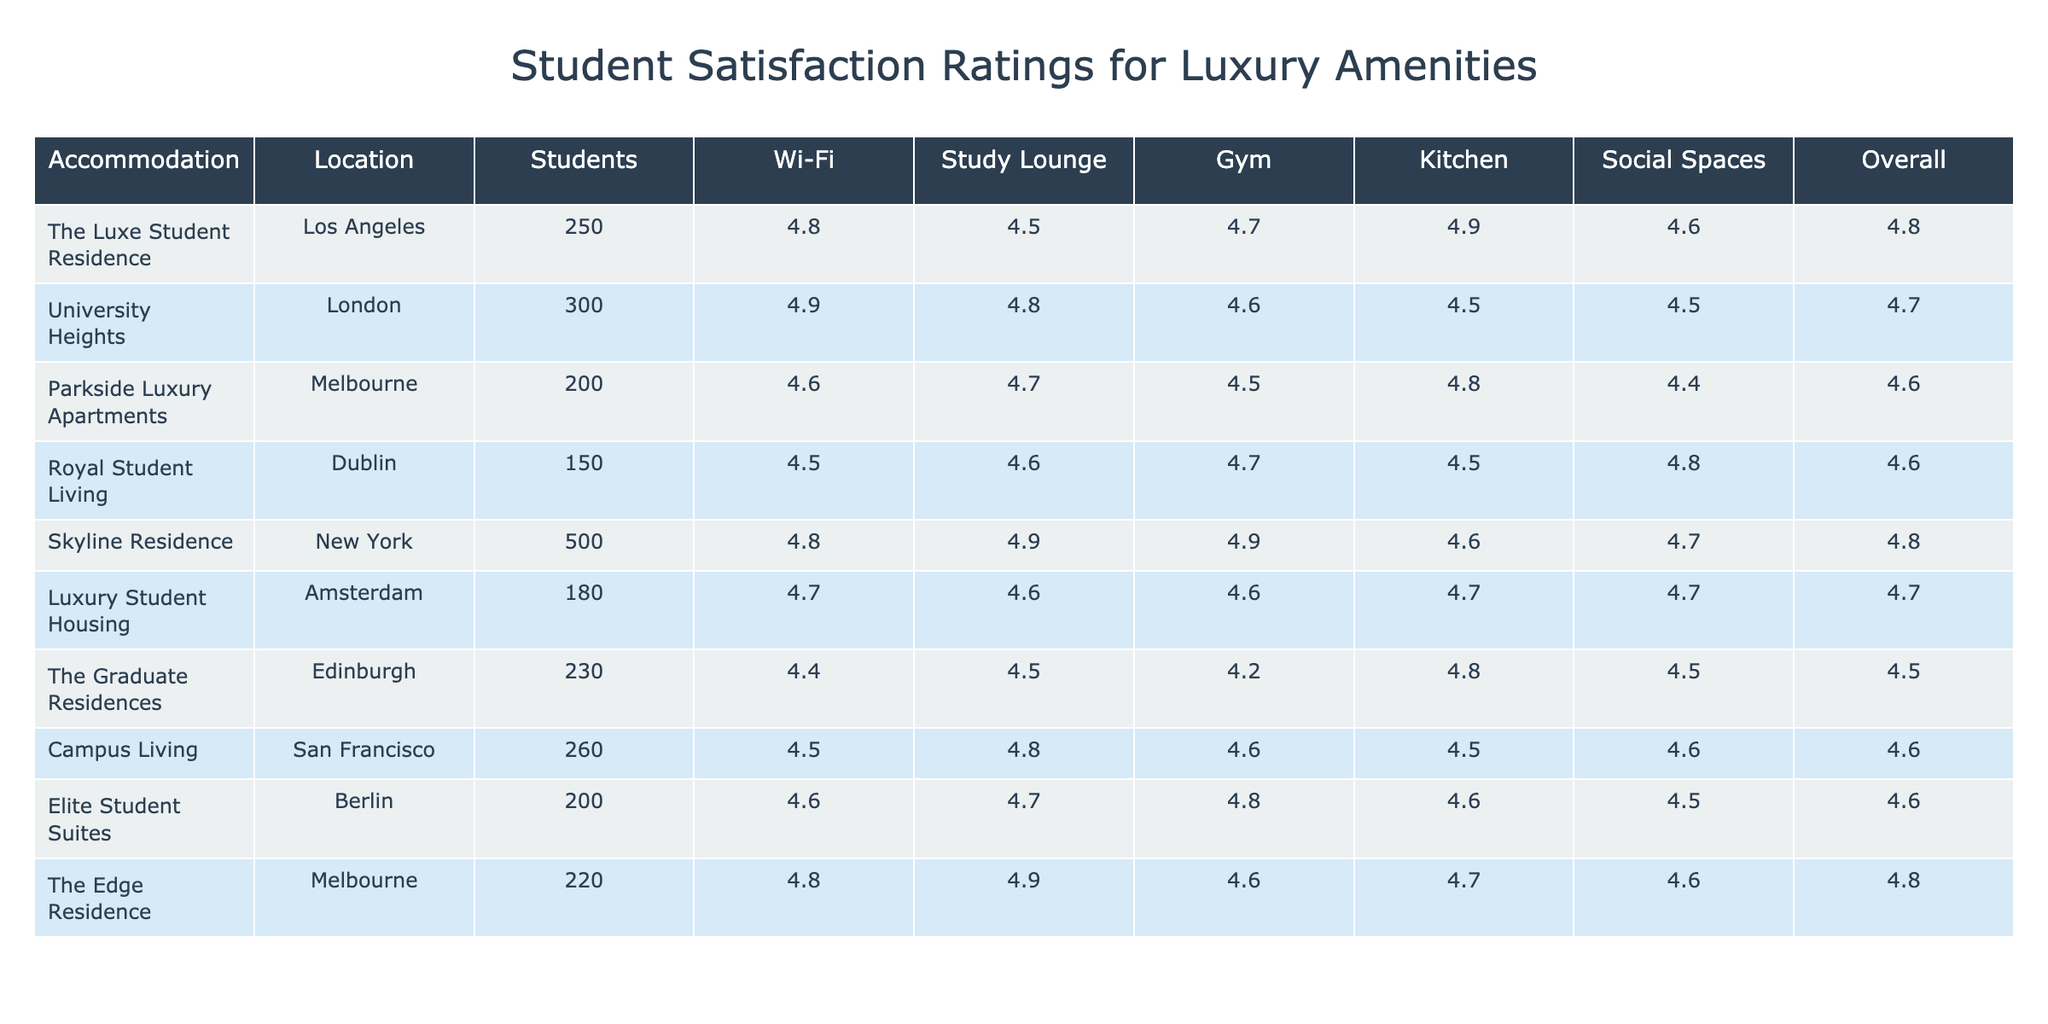What is the highest Wi-Fi quality rating among the facilities? To find the highest Wi-Fi quality rating, look at the "Wi-Fi" column and identify the maximum value. The highest rating is 4.9.
Answer: 4.9 Which accommodation has the lowest overall satisfaction rating? To find the lowest overall satisfaction rating, examine the "Overall" column and identify the minimum value. The lowest rating is 4.5, found in The Graduate Residences and Royal Student Living.
Answer: The Graduate Residences and Royal Student Living What is the combined total of students across all accommodation facilities? To get the combined total of students, sum the values in the "Students" column: 250 + 300 + 200 + 150 + 500 + 180 + 230 + 260 + 200 + 220 = 2280.
Answer: 2280 What is the average Kitchen Facilities rating across all facilities? To calculate the average Kitchen Facilities rating, sum the ratings in the "Kitchen" column (4.9 + 4.5 + 4.8 + 4.5 + 4.6 + 4.7 + 4.8 + 4.5 + 4.6 + 4.7 = 46.2) and divide by the number of facilities (10), which results in an average of 4.62.
Answer: 4.62 Is the Social Spaces quality rating for Skyline Residence higher than the average rating for that category? First, determine the Social Spaces quality rating for Skyline Residence, which is 4.7. Next, calculate the average of the "Social Spaces" column (4.6, 4.5, 4.4, 4.8, 4.7, 4.7, 4.5, 4.6, 4.5, 4.6 = 45.5, divided by 10 = 4.55). Since 4.7 is greater than 4.55, the statement is true.
Answer: True Which location has the highest Gym quality rating and what is that rating? Review the "Gym" column for each location to find the maximum value, which is 4.9 from both Skyline Residence and The Edge Residence. The locations are New York and Melbourne.
Answer: New York and Melbourne, rating of 4.9 How many facilities have a Wi-Fi Quality Rating of 4.8 or higher? Count the entries in the "Wi-Fi" column that are 4.8 or higher. There are 6 such facilities: The Luxe Student Residence, University Heights, Skyline Residence, The Edge Residence, and another one (Luxury Student Housing with 4.7 does not qualify).
Answer: 5 What is the difference between the highest and lowest ratings for Study Lounge Quality among the accommodations? Identify the maximum Study Lounge rating (4.9 from The Edge Residence and Skyline Residence) and the minimum (4.5 from The Graduate Residences and University Heights). The difference is 4.9 - 4.5 = 0.4.
Answer: 0.4 Are all accommodation facilities rated higher than 4.0 for Social Spaces? Check the "Social Spaces" ratings for all facilities to confirm if all exceed 4.0. Minimum value is 4.4 (Parkside Luxury Apartments), confirming that all facilities meet the criteria.
Answer: Yes Which accommodation type has the most students and what is the satisfaction rating for that facility? The facility with the most students is Skyline Residence with 500 students. The corresponding Overall Satisfaction Rating for this facility is 4.8.
Answer: Skyline Residence, 4.8 